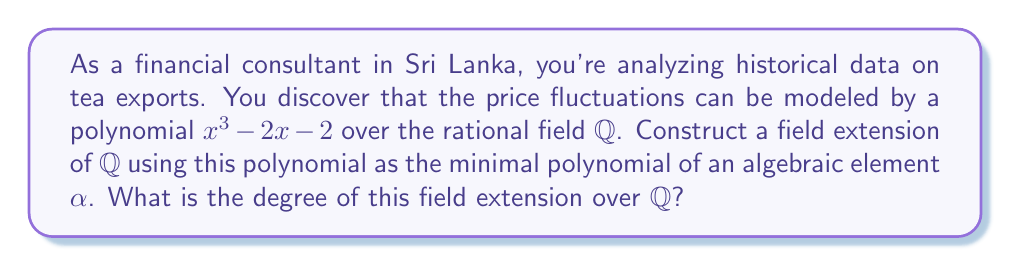Can you answer this question? Let's approach this step-by-step:

1) The polynomial $p(x) = x^3 - 2x - 2$ is given as the minimal polynomial of $\alpha$ over $\mathbb{Q}$.

2) To construct the field extension, we consider the quotient ring:

   $$\mathbb{Q}[x]/(p(x))$$

   This is the set of all polynomials with rational coefficients modulo $p(x)$.

3) Since $p(x)$ is irreducible over $\mathbb{Q}$ (as it's the minimal polynomial of $\alpha$), the quotient ring $\mathbb{Q}[x]/(p(x))$ is indeed a field.

4) This field is isomorphic to $\mathbb{Q}(\alpha)$, which is the smallest field containing both $\mathbb{Q}$ and $\alpha$.

5) The elements of this field can be written uniquely as:

   $$a + b\alpha + c\alpha^2$$

   where $a, b, c \in \mathbb{Q}$.

6) The degree of the field extension $[\mathbb{Q}(\alpha):\mathbb{Q}]$ is equal to the degree of the minimal polynomial $p(x)$.

7) The degree of $p(x) = x^3 - 2x - 2$ is 3.

Therefore, the degree of the field extension $\mathbb{Q}(\alpha)$ over $\mathbb{Q}$ is 3.
Answer: 3 